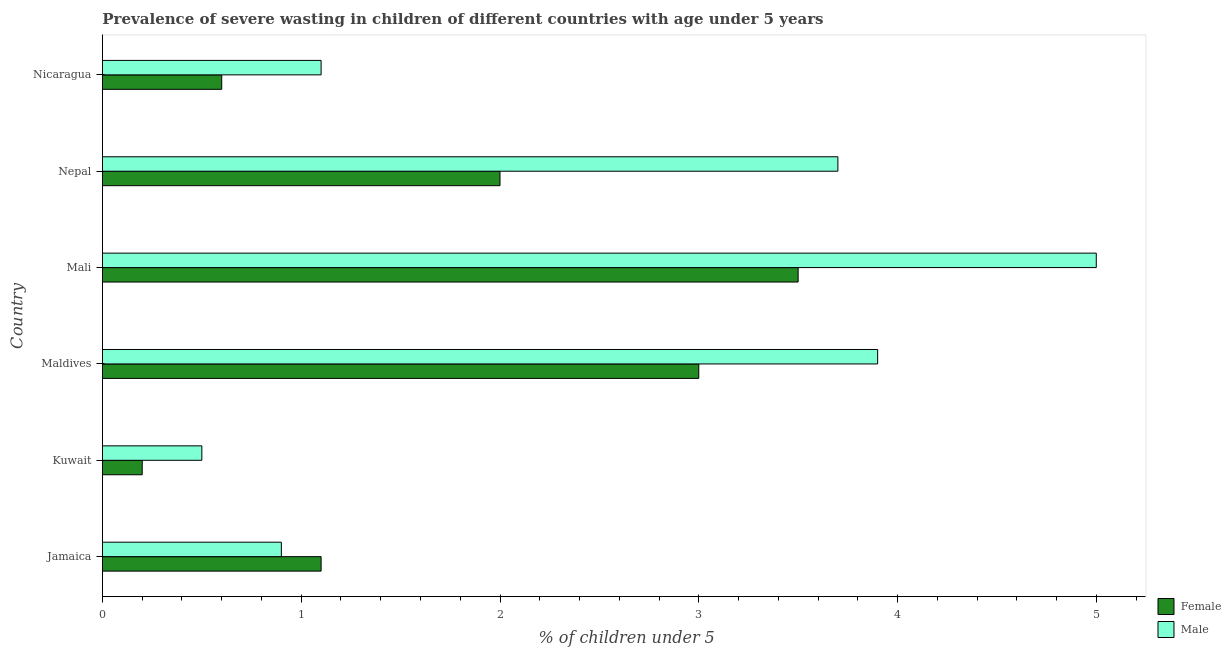How many different coloured bars are there?
Keep it short and to the point. 2. How many groups of bars are there?
Your answer should be compact. 6. Are the number of bars on each tick of the Y-axis equal?
Your response must be concise. Yes. What is the label of the 3rd group of bars from the top?
Make the answer very short. Mali. In how many cases, is the number of bars for a given country not equal to the number of legend labels?
Make the answer very short. 0. What is the percentage of undernourished male children in Nicaragua?
Your answer should be very brief. 1.1. Across all countries, what is the minimum percentage of undernourished female children?
Give a very brief answer. 0.2. In which country was the percentage of undernourished male children maximum?
Provide a short and direct response. Mali. In which country was the percentage of undernourished male children minimum?
Offer a terse response. Kuwait. What is the total percentage of undernourished female children in the graph?
Your answer should be compact. 10.4. What is the average percentage of undernourished female children per country?
Provide a succinct answer. 1.73. What is the difference between the percentage of undernourished male children and percentage of undernourished female children in Kuwait?
Your answer should be compact. 0.3. In how many countries, is the percentage of undernourished female children greater than 4 %?
Your answer should be very brief. 0. What is the difference between the highest and the second highest percentage of undernourished male children?
Offer a very short reply. 1.1. What is the difference between the highest and the lowest percentage of undernourished female children?
Offer a terse response. 3.3. Is the sum of the percentage of undernourished female children in Maldives and Mali greater than the maximum percentage of undernourished male children across all countries?
Offer a very short reply. Yes. What does the 2nd bar from the top in Kuwait represents?
Your answer should be very brief. Female. What does the 1st bar from the bottom in Jamaica represents?
Provide a short and direct response. Female. Are all the bars in the graph horizontal?
Your response must be concise. Yes. How many countries are there in the graph?
Provide a succinct answer. 6. Are the values on the major ticks of X-axis written in scientific E-notation?
Your answer should be compact. No. Does the graph contain grids?
Provide a short and direct response. No. Where does the legend appear in the graph?
Give a very brief answer. Bottom right. How many legend labels are there?
Make the answer very short. 2. What is the title of the graph?
Offer a terse response. Prevalence of severe wasting in children of different countries with age under 5 years. Does "Secondary school" appear as one of the legend labels in the graph?
Provide a succinct answer. No. What is the label or title of the X-axis?
Give a very brief answer.  % of children under 5. What is the  % of children under 5 of Female in Jamaica?
Provide a short and direct response. 1.1. What is the  % of children under 5 in Male in Jamaica?
Provide a succinct answer. 0.9. What is the  % of children under 5 in Female in Kuwait?
Make the answer very short. 0.2. What is the  % of children under 5 of Male in Kuwait?
Offer a terse response. 0.5. What is the  % of children under 5 in Female in Maldives?
Provide a short and direct response. 3. What is the  % of children under 5 in Male in Maldives?
Provide a succinct answer. 3.9. What is the  % of children under 5 in Male in Mali?
Ensure brevity in your answer.  5. What is the  % of children under 5 of Male in Nepal?
Your response must be concise. 3.7. What is the  % of children under 5 in Female in Nicaragua?
Your answer should be compact. 0.6. What is the  % of children under 5 of Male in Nicaragua?
Your response must be concise. 1.1. Across all countries, what is the maximum  % of children under 5 in Male?
Your response must be concise. 5. Across all countries, what is the minimum  % of children under 5 of Female?
Ensure brevity in your answer.  0.2. Across all countries, what is the minimum  % of children under 5 of Male?
Offer a terse response. 0.5. What is the total  % of children under 5 of Female in the graph?
Make the answer very short. 10.4. What is the total  % of children under 5 of Male in the graph?
Provide a short and direct response. 15.1. What is the difference between the  % of children under 5 of Female in Jamaica and that in Kuwait?
Your response must be concise. 0.9. What is the difference between the  % of children under 5 in Female in Jamaica and that in Nicaragua?
Your response must be concise. 0.5. What is the difference between the  % of children under 5 in Male in Kuwait and that in Nepal?
Provide a succinct answer. -3.2. What is the difference between the  % of children under 5 of Male in Kuwait and that in Nicaragua?
Your answer should be very brief. -0.6. What is the difference between the  % of children under 5 in Male in Maldives and that in Mali?
Give a very brief answer. -1.1. What is the difference between the  % of children under 5 of Female in Maldives and that in Nepal?
Offer a terse response. 1. What is the difference between the  % of children under 5 in Male in Maldives and that in Nepal?
Your response must be concise. 0.2. What is the difference between the  % of children under 5 in Female in Maldives and that in Nicaragua?
Your answer should be compact. 2.4. What is the difference between the  % of children under 5 in Female in Mali and that in Nepal?
Ensure brevity in your answer.  1.5. What is the difference between the  % of children under 5 in Male in Mali and that in Nepal?
Keep it short and to the point. 1.3. What is the difference between the  % of children under 5 in Male in Mali and that in Nicaragua?
Your answer should be compact. 3.9. What is the difference between the  % of children under 5 in Male in Nepal and that in Nicaragua?
Make the answer very short. 2.6. What is the difference between the  % of children under 5 in Female in Kuwait and the  % of children under 5 in Male in Maldives?
Your answer should be compact. -3.7. What is the difference between the  % of children under 5 in Female in Kuwait and the  % of children under 5 in Male in Mali?
Provide a short and direct response. -4.8. What is the difference between the  % of children under 5 in Female in Maldives and the  % of children under 5 in Male in Mali?
Provide a succinct answer. -2. What is the difference between the  % of children under 5 of Female in Mali and the  % of children under 5 of Male in Nepal?
Keep it short and to the point. -0.2. What is the average  % of children under 5 of Female per country?
Ensure brevity in your answer.  1.73. What is the average  % of children under 5 in Male per country?
Your answer should be very brief. 2.52. What is the difference between the  % of children under 5 of Female and  % of children under 5 of Male in Jamaica?
Ensure brevity in your answer.  0.2. What is the difference between the  % of children under 5 in Female and  % of children under 5 in Male in Nepal?
Your response must be concise. -1.7. What is the ratio of the  % of children under 5 of Male in Jamaica to that in Kuwait?
Offer a terse response. 1.8. What is the ratio of the  % of children under 5 in Female in Jamaica to that in Maldives?
Provide a succinct answer. 0.37. What is the ratio of the  % of children under 5 of Male in Jamaica to that in Maldives?
Provide a short and direct response. 0.23. What is the ratio of the  % of children under 5 of Female in Jamaica to that in Mali?
Provide a succinct answer. 0.31. What is the ratio of the  % of children under 5 in Male in Jamaica to that in Mali?
Keep it short and to the point. 0.18. What is the ratio of the  % of children under 5 of Female in Jamaica to that in Nepal?
Your answer should be compact. 0.55. What is the ratio of the  % of children under 5 of Male in Jamaica to that in Nepal?
Provide a succinct answer. 0.24. What is the ratio of the  % of children under 5 of Female in Jamaica to that in Nicaragua?
Offer a terse response. 1.83. What is the ratio of the  % of children under 5 in Male in Jamaica to that in Nicaragua?
Offer a terse response. 0.82. What is the ratio of the  % of children under 5 of Female in Kuwait to that in Maldives?
Provide a succinct answer. 0.07. What is the ratio of the  % of children under 5 of Male in Kuwait to that in Maldives?
Make the answer very short. 0.13. What is the ratio of the  % of children under 5 of Female in Kuwait to that in Mali?
Your answer should be very brief. 0.06. What is the ratio of the  % of children under 5 of Male in Kuwait to that in Mali?
Offer a terse response. 0.1. What is the ratio of the  % of children under 5 of Male in Kuwait to that in Nepal?
Provide a short and direct response. 0.14. What is the ratio of the  % of children under 5 of Female in Kuwait to that in Nicaragua?
Your answer should be very brief. 0.33. What is the ratio of the  % of children under 5 of Male in Kuwait to that in Nicaragua?
Keep it short and to the point. 0.45. What is the ratio of the  % of children under 5 in Female in Maldives to that in Mali?
Give a very brief answer. 0.86. What is the ratio of the  % of children under 5 of Male in Maldives to that in Mali?
Give a very brief answer. 0.78. What is the ratio of the  % of children under 5 in Male in Maldives to that in Nepal?
Your response must be concise. 1.05. What is the ratio of the  % of children under 5 in Female in Maldives to that in Nicaragua?
Provide a short and direct response. 5. What is the ratio of the  % of children under 5 in Male in Maldives to that in Nicaragua?
Your answer should be compact. 3.55. What is the ratio of the  % of children under 5 in Female in Mali to that in Nepal?
Provide a short and direct response. 1.75. What is the ratio of the  % of children under 5 in Male in Mali to that in Nepal?
Provide a succinct answer. 1.35. What is the ratio of the  % of children under 5 in Female in Mali to that in Nicaragua?
Provide a short and direct response. 5.83. What is the ratio of the  % of children under 5 of Male in Mali to that in Nicaragua?
Make the answer very short. 4.55. What is the ratio of the  % of children under 5 of Female in Nepal to that in Nicaragua?
Your response must be concise. 3.33. What is the ratio of the  % of children under 5 of Male in Nepal to that in Nicaragua?
Provide a short and direct response. 3.36. 